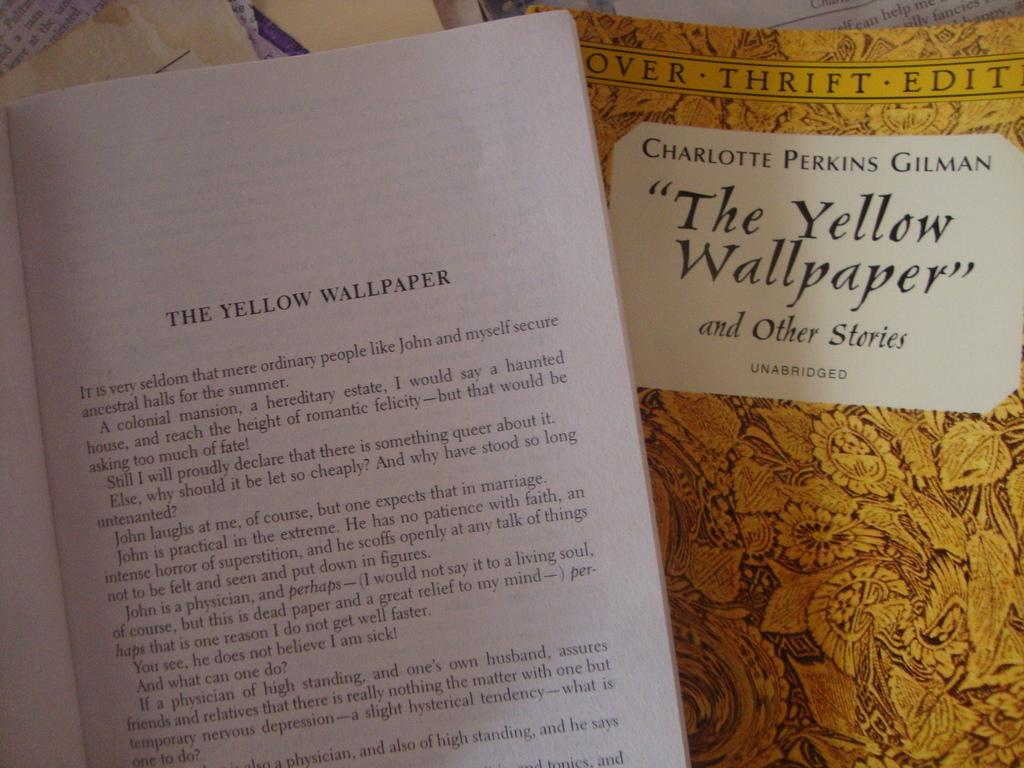<image>
Render a clear and concise summary of the photo. The Yellow Wallpaper, by Charlotte Perkins Gilman, has a yellow cover 